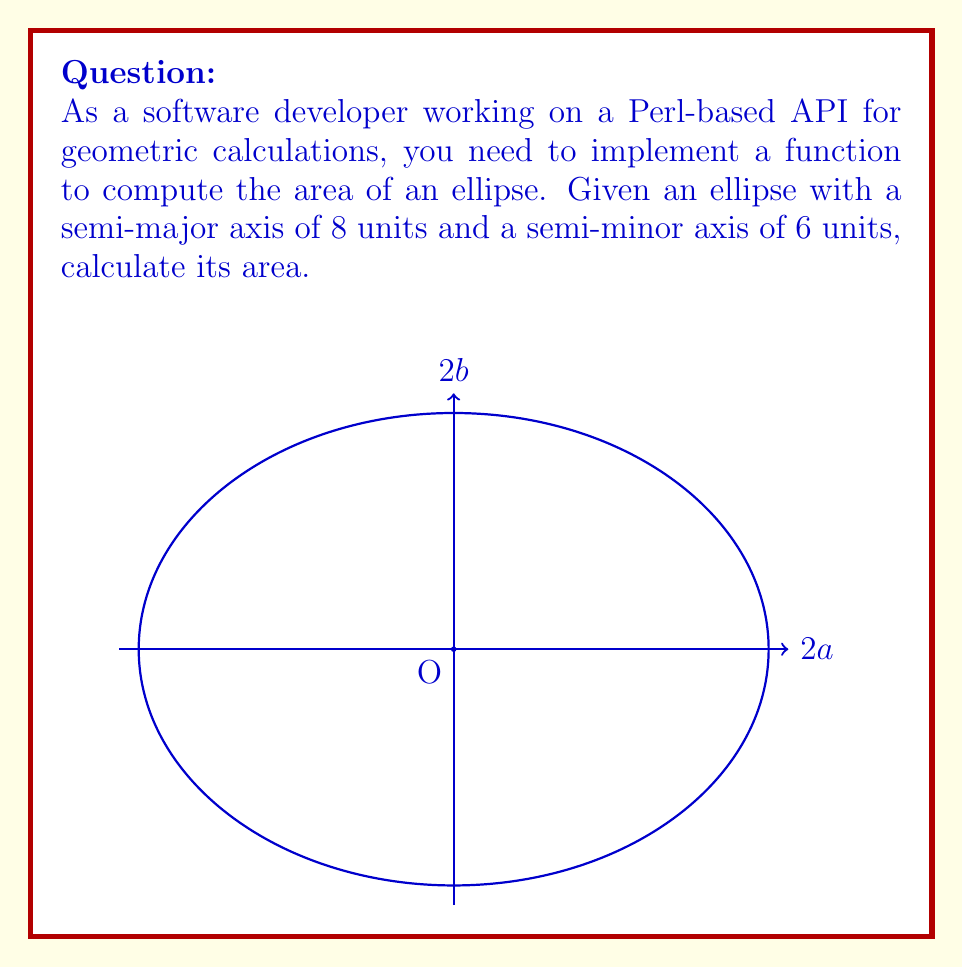What is the answer to this math problem? To calculate the area of an ellipse, we use the formula:

$$A = \pi ab$$

Where:
$A$ is the area of the ellipse
$a$ is the length of the semi-major axis
$b$ is the length of the semi-minor axis
$\pi$ is the mathematical constant pi (approximately 3.14159)

Given:
Semi-major axis, $a = 8$ units
Semi-minor axis, $b = 6$ units

Step 1: Substitute the values into the formula
$$A = \pi \cdot 8 \cdot 6$$

Step 2: Multiply the values
$$A = \pi \cdot 48$$

Step 3: Calculate the final result
$$A = 48\pi \approx 150.80 \text{ square units}$$

In your Perl implementation, you could use the Math::Trig module to get a more precise value of $\pi$:

```perl
use Math::Trig qw(pi);
my $area = pi * 8 * 6;
```

This would give you a more accurate result for API calculations.
Answer: $48\pi$ square units 